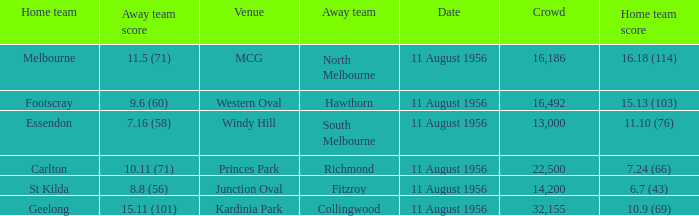What is the home team score for Footscray? 15.13 (103). 